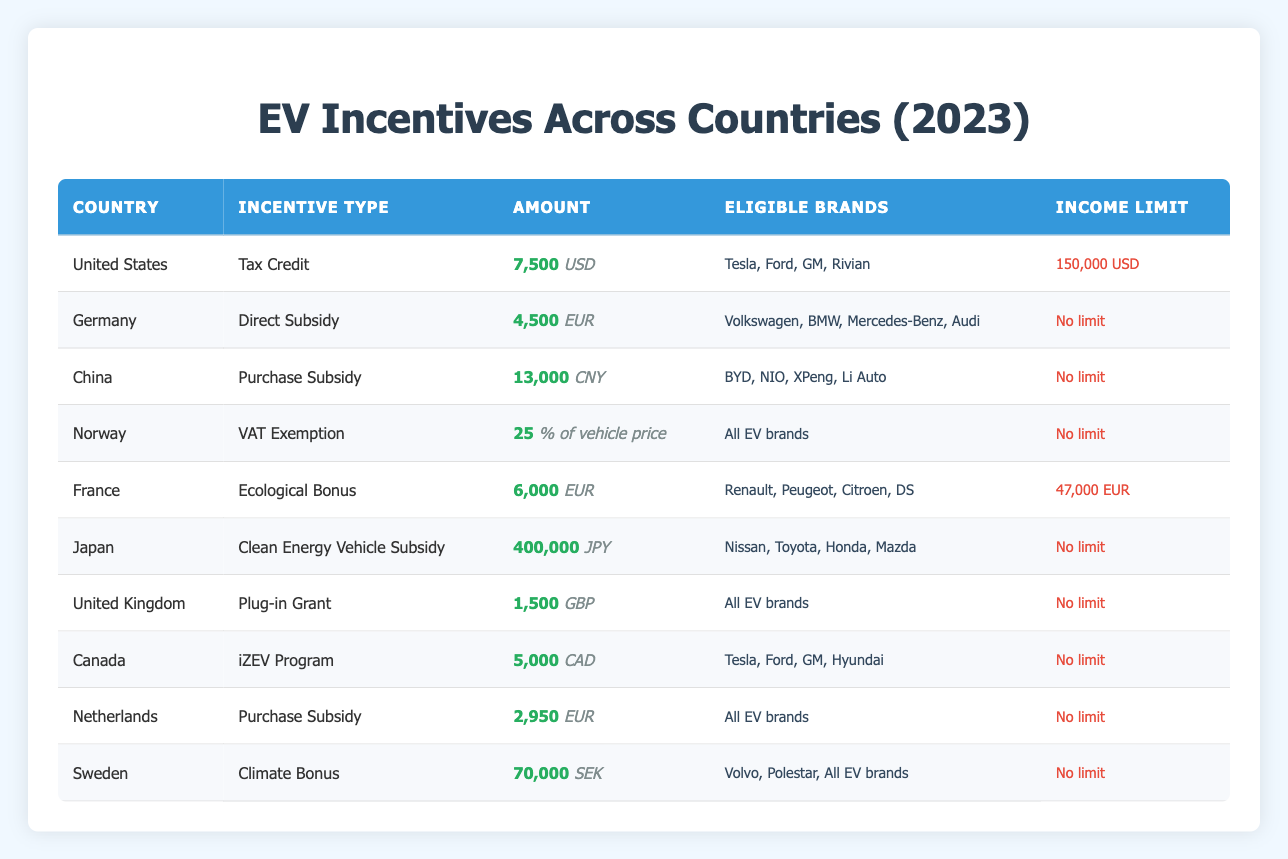What is the amount of the Tax Credit incentive for the United States? The table indicates that the amount for the Tax Credit incentive in the United States is 7500 USD.
Answer: 7500 USD Which country offers the highest amount of government incentive for EV purchases? A comparison of the amounts listed shows that China offers the highest incentive at 13000 CNY, as no other country has an amount exceeding this.
Answer: 13000 CNY Is there an income limit for the Clean Energy Vehicle Subsidy in Japan? According to the table, Japan has no income limit listed for the Clean Energy Vehicle Subsidy, so the answer is no.
Answer: No How much is the VAT Exemption incentive in Norway expressed as a percentage of the vehicle price? The VAT Exemption incentive in Norway is expressed as 25% of the vehicle price, as stated in the table.
Answer: 25% of vehicle price Which countries have incentives with no income limits? By reviewing the table, the countries without specified income limits include Germany, China, Norway, Japan, United Kingdom, Netherlands, and Sweden, totaling seven countries.
Answer: Seven countries (Germany, China, Norway, Japan, UK, Netherlands, Sweden) What is the average incentive amount for countries that have a direct cash subsidy? The countries offering cash subsidies (Germany, China, and France) have amounts of 4500 EUR, 13000 CNY, and 6000 EUR, respectively. Converting all amounts to a common currency (assuming 1 EUR = 1.1 USD, 1 CNY = 0.15 USD), we calculate: 4500 EUR * 1.1 = 4950 USD, 13000 CNY * 0.15 = 1950 USD, and 6000 EUR * 1.1 = 6600 USD. The average is (4950 + 1950 + 6600) / 3 = 4500 USD.
Answer: 4500 USD Is the Plug-in Grant in the United Kingdom equal to or less than 2000 GBP? The table shows that the Plug-in Grant in the UK is 1500 GBP, which is less than 2000 GBP. Therefore, the answer to the question is yes.
Answer: Yes How many countries provide subsidies specifically for Tesla and Ford? A review of the table indicates that both Tesla and Ford are eligible for subsidies in the United States and Canada. Thus, there are two countries that provide these subsidies.
Answer: Two countries (United States, Canada) What is the difference between the highest and lowest incentive amounts across the listed countries? The highest amount is 13000 CNY from China and the lowest is 25% of vehicle price from Norway. Converting Norway's incentive amount to a comparable dollar value requires estimable vehicle costs, but here interpreting percentage values does not lend itself to a straightforward dollar value without assumptions. Instead, we focus on the absolute monetary amount: by ignoring the percentage and comparing CNY and incentives listed directly, the difference can be roughly quantified from the cash amounts, which shows a clear gap of (13000 - effective monetary value of 25% could be variable). However, in terms of cash incentives, the absolute difference is clearly extensive. Therefore, we can say there’s a significant difference present, though quantifying exact difference requires assumptions on vehicle pricing.
Answer: Significant difference 